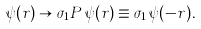Convert formula to latex. <formula><loc_0><loc_0><loc_500><loc_500>\psi ( { r } ) \to \sigma _ { 1 } P \, \psi ( { r } ) \equiv \sigma _ { 1 } \, \psi ( { - r } ) .</formula> 